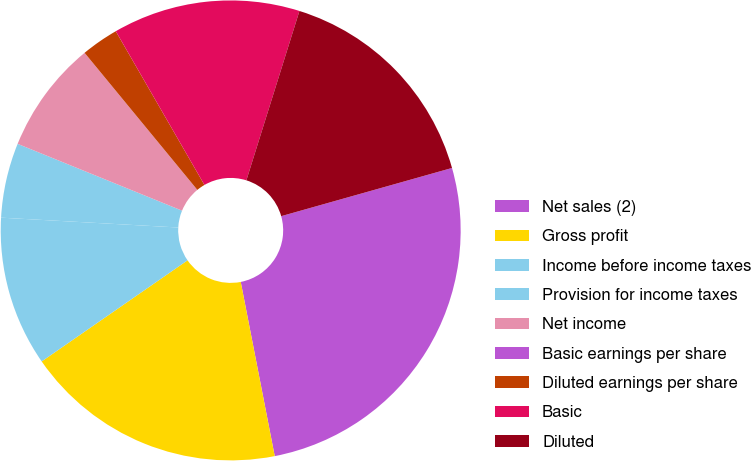Convert chart. <chart><loc_0><loc_0><loc_500><loc_500><pie_chart><fcel>Net sales (2)<fcel>Gross profit<fcel>Income before income taxes<fcel>Provision for income taxes<fcel>Net income<fcel>Basic earnings per share<fcel>Diluted earnings per share<fcel>Basic<fcel>Diluted<nl><fcel>26.31%<fcel>18.42%<fcel>10.53%<fcel>5.26%<fcel>7.9%<fcel>0.0%<fcel>2.63%<fcel>13.16%<fcel>15.79%<nl></chart> 